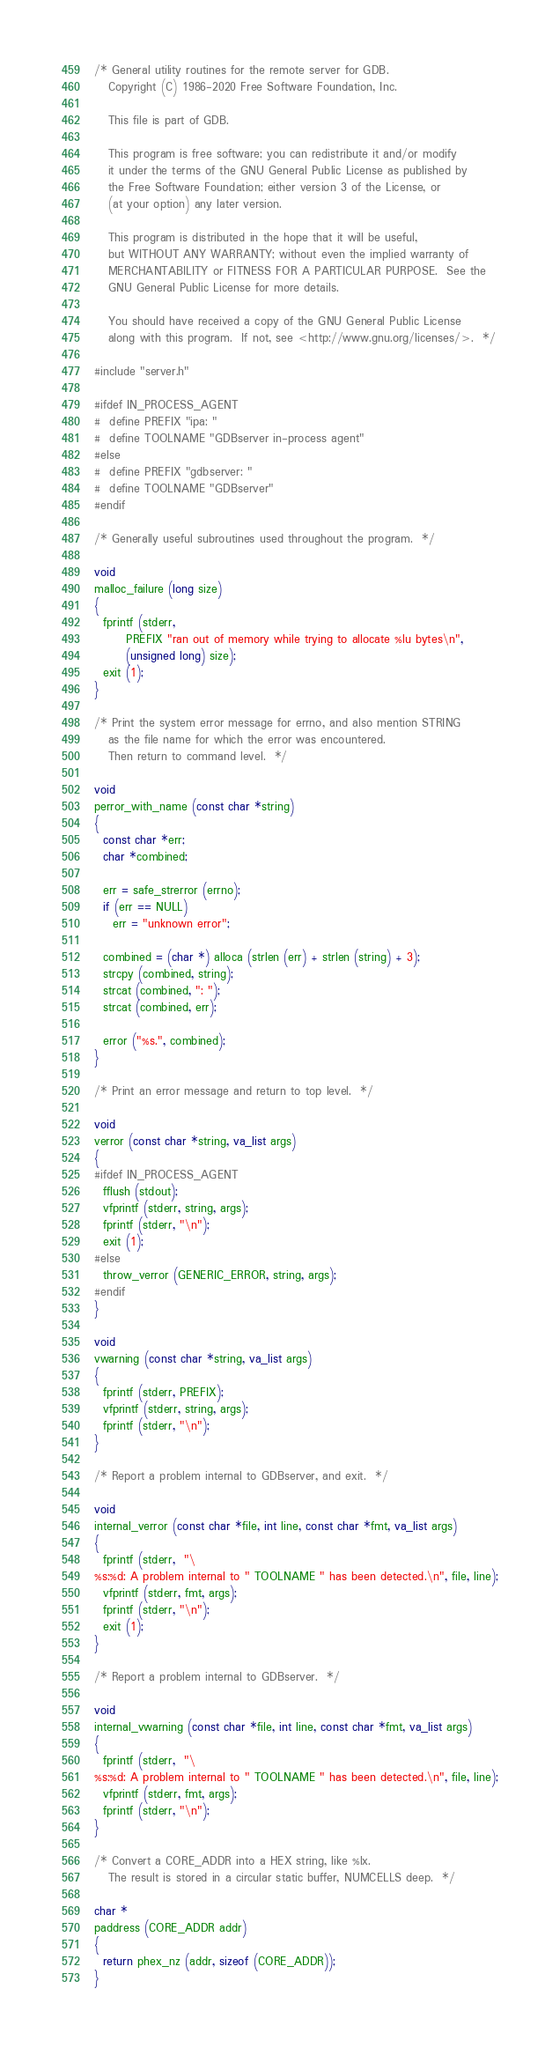<code> <loc_0><loc_0><loc_500><loc_500><_C++_>/* General utility routines for the remote server for GDB.
   Copyright (C) 1986-2020 Free Software Foundation, Inc.

   This file is part of GDB.

   This program is free software; you can redistribute it and/or modify
   it under the terms of the GNU General Public License as published by
   the Free Software Foundation; either version 3 of the License, or
   (at your option) any later version.

   This program is distributed in the hope that it will be useful,
   but WITHOUT ANY WARRANTY; without even the implied warranty of
   MERCHANTABILITY or FITNESS FOR A PARTICULAR PURPOSE.  See the
   GNU General Public License for more details.

   You should have received a copy of the GNU General Public License
   along with this program.  If not, see <http://www.gnu.org/licenses/>.  */

#include "server.h"

#ifdef IN_PROCESS_AGENT
#  define PREFIX "ipa: "
#  define TOOLNAME "GDBserver in-process agent"
#else
#  define PREFIX "gdbserver: "
#  define TOOLNAME "GDBserver"
#endif

/* Generally useful subroutines used throughout the program.  */

void
malloc_failure (long size)
{
  fprintf (stderr,
	   PREFIX "ran out of memory while trying to allocate %lu bytes\n",
	   (unsigned long) size);
  exit (1);
}

/* Print the system error message for errno, and also mention STRING
   as the file name for which the error was encountered.
   Then return to command level.  */

void
perror_with_name (const char *string)
{
  const char *err;
  char *combined;

  err = safe_strerror (errno);
  if (err == NULL)
    err = "unknown error";

  combined = (char *) alloca (strlen (err) + strlen (string) + 3);
  strcpy (combined, string);
  strcat (combined, ": ");
  strcat (combined, err);

  error ("%s.", combined);
}

/* Print an error message and return to top level.  */

void
verror (const char *string, va_list args)
{
#ifdef IN_PROCESS_AGENT
  fflush (stdout);
  vfprintf (stderr, string, args);
  fprintf (stderr, "\n");
  exit (1);
#else
  throw_verror (GENERIC_ERROR, string, args);
#endif
}

void
vwarning (const char *string, va_list args)
{
  fprintf (stderr, PREFIX);
  vfprintf (stderr, string, args);
  fprintf (stderr, "\n");
}

/* Report a problem internal to GDBserver, and exit.  */

void
internal_verror (const char *file, int line, const char *fmt, va_list args)
{
  fprintf (stderr,  "\
%s:%d: A problem internal to " TOOLNAME " has been detected.\n", file, line);
  vfprintf (stderr, fmt, args);
  fprintf (stderr, "\n");
  exit (1);
}

/* Report a problem internal to GDBserver.  */

void
internal_vwarning (const char *file, int line, const char *fmt, va_list args)
{
  fprintf (stderr,  "\
%s:%d: A problem internal to " TOOLNAME " has been detected.\n", file, line);
  vfprintf (stderr, fmt, args);
  fprintf (stderr, "\n");
}

/* Convert a CORE_ADDR into a HEX string, like %lx.
   The result is stored in a circular static buffer, NUMCELLS deep.  */

char *
paddress (CORE_ADDR addr)
{
  return phex_nz (addr, sizeof (CORE_ADDR));
}
</code> 